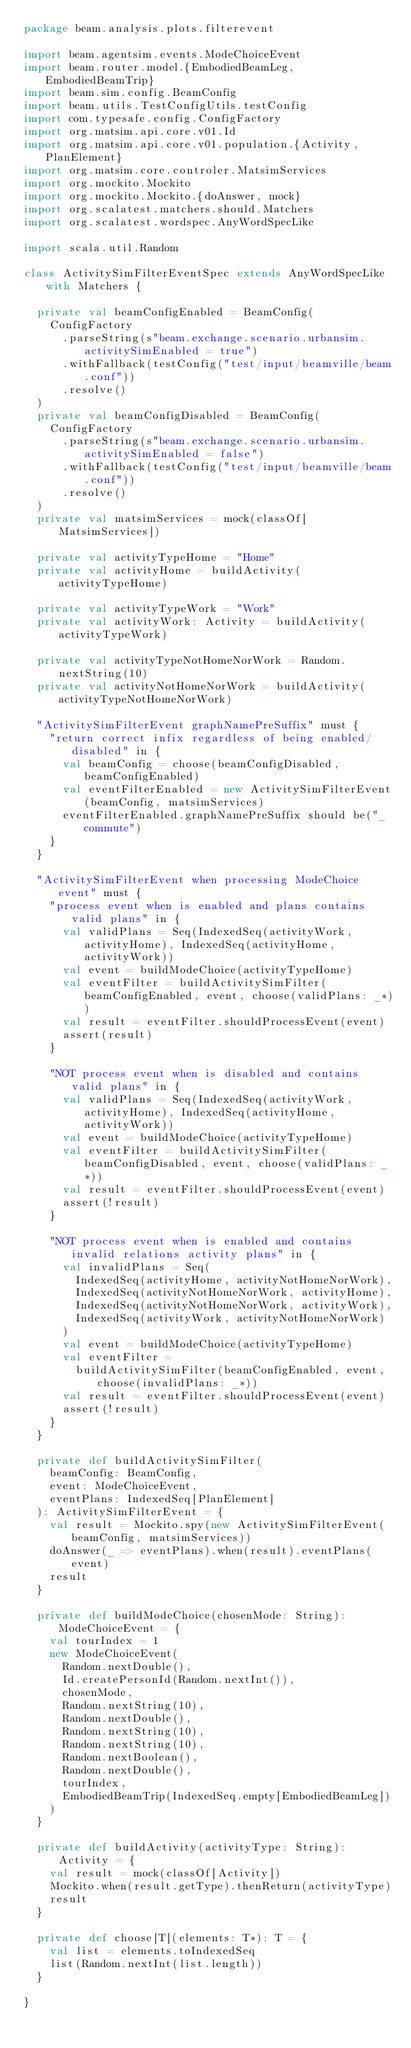Convert code to text. <code><loc_0><loc_0><loc_500><loc_500><_Scala_>package beam.analysis.plots.filterevent

import beam.agentsim.events.ModeChoiceEvent
import beam.router.model.{EmbodiedBeamLeg, EmbodiedBeamTrip}
import beam.sim.config.BeamConfig
import beam.utils.TestConfigUtils.testConfig
import com.typesafe.config.ConfigFactory
import org.matsim.api.core.v01.Id
import org.matsim.api.core.v01.population.{Activity, PlanElement}
import org.matsim.core.controler.MatsimServices
import org.mockito.Mockito
import org.mockito.Mockito.{doAnswer, mock}
import org.scalatest.matchers.should.Matchers
import org.scalatest.wordspec.AnyWordSpecLike

import scala.util.Random

class ActivitySimFilterEventSpec extends AnyWordSpecLike with Matchers {

  private val beamConfigEnabled = BeamConfig(
    ConfigFactory
      .parseString(s"beam.exchange.scenario.urbansim.activitySimEnabled = true")
      .withFallback(testConfig("test/input/beamville/beam.conf"))
      .resolve()
  )
  private val beamConfigDisabled = BeamConfig(
    ConfigFactory
      .parseString(s"beam.exchange.scenario.urbansim.activitySimEnabled = false")
      .withFallback(testConfig("test/input/beamville/beam.conf"))
      .resolve()
  )
  private val matsimServices = mock(classOf[MatsimServices])

  private val activityTypeHome = "Home"
  private val activityHome = buildActivity(activityTypeHome)

  private val activityTypeWork = "Work"
  private val activityWork: Activity = buildActivity(activityTypeWork)

  private val activityTypeNotHomeNorWork = Random.nextString(10)
  private val activityNotHomeNorWork = buildActivity(activityTypeNotHomeNorWork)

  "ActivitySimFilterEvent graphNamePreSuffix" must {
    "return correct infix regardless of being enabled/disabled" in {
      val beamConfig = choose(beamConfigDisabled, beamConfigEnabled)
      val eventFilterEnabled = new ActivitySimFilterEvent(beamConfig, matsimServices)
      eventFilterEnabled.graphNamePreSuffix should be("_commute")
    }
  }

  "ActivitySimFilterEvent when processing ModeChoice event" must {
    "process event when is enabled and plans contains valid plans" in {
      val validPlans = Seq(IndexedSeq(activityWork, activityHome), IndexedSeq(activityHome, activityWork))
      val event = buildModeChoice(activityTypeHome)
      val eventFilter = buildActivitySimFilter(beamConfigEnabled, event, choose(validPlans: _*))
      val result = eventFilter.shouldProcessEvent(event)
      assert(result)
    }

    "NOT process event when is disabled and contains valid plans" in {
      val validPlans = Seq(IndexedSeq(activityWork, activityHome), IndexedSeq(activityHome, activityWork))
      val event = buildModeChoice(activityTypeHome)
      val eventFilter = buildActivitySimFilter(beamConfigDisabled, event, choose(validPlans: _*))
      val result = eventFilter.shouldProcessEvent(event)
      assert(!result)
    }

    "NOT process event when is enabled and contains invalid relations activity plans" in {
      val invalidPlans = Seq(
        IndexedSeq(activityHome, activityNotHomeNorWork),
        IndexedSeq(activityNotHomeNorWork, activityHome),
        IndexedSeq(activityNotHomeNorWork, activityWork),
        IndexedSeq(activityWork, activityNotHomeNorWork)
      )
      val event = buildModeChoice(activityTypeHome)
      val eventFilter =
        buildActivitySimFilter(beamConfigEnabled, event, choose(invalidPlans: _*))
      val result = eventFilter.shouldProcessEvent(event)
      assert(!result)
    }
  }

  private def buildActivitySimFilter(
    beamConfig: BeamConfig,
    event: ModeChoiceEvent,
    eventPlans: IndexedSeq[PlanElement]
  ): ActivitySimFilterEvent = {
    val result = Mockito.spy(new ActivitySimFilterEvent(beamConfig, matsimServices))
    doAnswer(_ => eventPlans).when(result).eventPlans(event)
    result
  }

  private def buildModeChoice(chosenMode: String): ModeChoiceEvent = {
    val tourIndex = 1
    new ModeChoiceEvent(
      Random.nextDouble(),
      Id.createPersonId(Random.nextInt()),
      chosenMode,
      Random.nextString(10),
      Random.nextDouble(),
      Random.nextString(10),
      Random.nextString(10),
      Random.nextBoolean(),
      Random.nextDouble(),
      tourIndex,
      EmbodiedBeamTrip(IndexedSeq.empty[EmbodiedBeamLeg])
    )
  }

  private def buildActivity(activityType: String): Activity = {
    val result = mock(classOf[Activity])
    Mockito.when(result.getType).thenReturn(activityType)
    result
  }

  private def choose[T](elements: T*): T = {
    val list = elements.toIndexedSeq
    list(Random.nextInt(list.length))
  }

}
</code> 